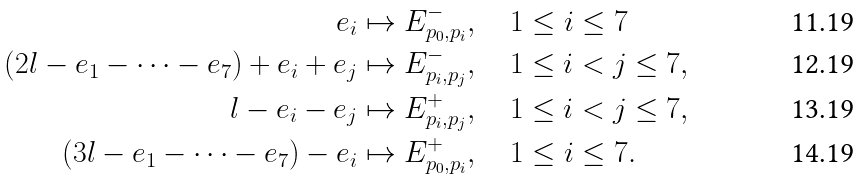<formula> <loc_0><loc_0><loc_500><loc_500>e _ { i } & \mapsto E _ { p _ { 0 } , p _ { i } } ^ { - } , \quad 1 \leq i \leq 7 \\ ( 2 l - e _ { 1 } - \cdots - e _ { 7 } ) + e _ { i } + e _ { j } & \mapsto E _ { p _ { i } , p _ { j } } ^ { - } , \quad 1 \leq i < j \leq 7 , \\ l - e _ { i } - e _ { j } & \mapsto E _ { p _ { i } , p _ { j } } ^ { + } , \quad 1 \leq i < j \leq 7 , \\ ( 3 l - e _ { 1 } - \cdots - e _ { 7 } ) - e _ { i } & \mapsto E _ { p _ { 0 } , p _ { i } } ^ { + } , \quad 1 \leq i \leq 7 .</formula> 